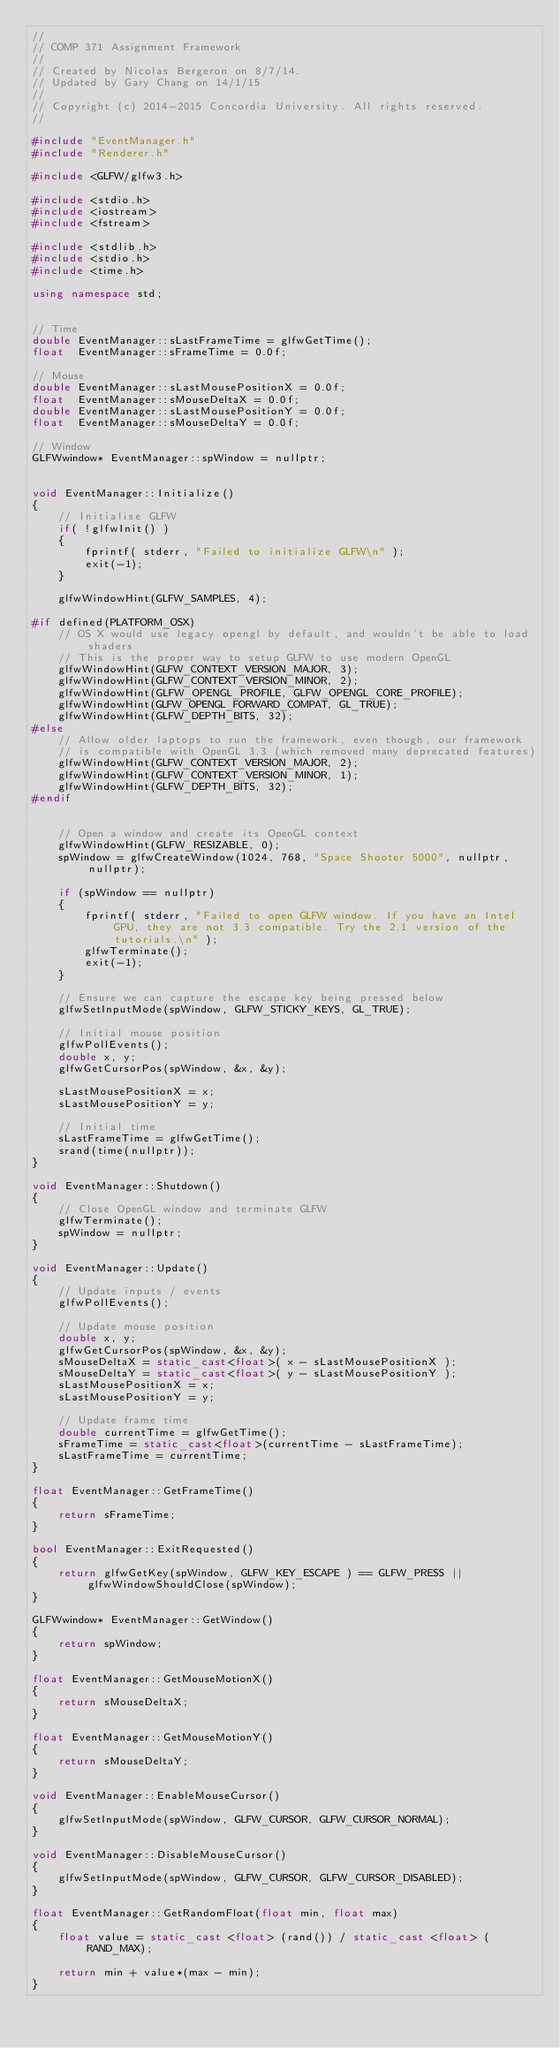Convert code to text. <code><loc_0><loc_0><loc_500><loc_500><_C++_>//
// COMP 371 Assignment Framework
//
// Created by Nicolas Bergeron on 8/7/14.
// Updated by Gary Chang on 14/1/15
//
// Copyright (c) 2014-2015 Concordia University. All rights reserved.
//

#include "EventManager.h"
#include "Renderer.h"

#include <GLFW/glfw3.h>

#include <stdio.h>
#include <iostream>
#include <fstream>

#include <stdlib.h>
#include <stdio.h>
#include <time.h>

using namespace std;


// Time
double EventManager::sLastFrameTime = glfwGetTime();
float  EventManager::sFrameTime = 0.0f;

// Mouse
double EventManager::sLastMousePositionX = 0.0f;
float  EventManager::sMouseDeltaX = 0.0f;
double EventManager::sLastMousePositionY = 0.0f;
float  EventManager::sMouseDeltaY = 0.0f;

// Window
GLFWwindow* EventManager::spWindow = nullptr;


void EventManager::Initialize()
{
	// Initialise GLFW
	if( !glfwInit() )
	{
		fprintf( stderr, "Failed to initialize GLFW\n" );
		exit(-1);
	}
		
	glfwWindowHint(GLFW_SAMPLES, 4);
    
#if defined(PLATFORM_OSX)
    // OS X would use legacy opengl by default, and wouldn't be able to load shaders
    // This is the proper way to setup GLFW to use modern OpenGL
    glfwWindowHint(GLFW_CONTEXT_VERSION_MAJOR, 3);
    glfwWindowHint(GLFW_CONTEXT_VERSION_MINOR, 2);
    glfwWindowHint(GLFW_OPENGL_PROFILE, GLFW_OPENGL_CORE_PROFILE);
    glfwWindowHint(GLFW_OPENGL_FORWARD_COMPAT, GL_TRUE);
	glfwWindowHint(GLFW_DEPTH_BITS, 32);
#else
    // Allow older laptops to run the framework, even though, our framework
    // is compatible with OpenGL 3.3 (which removed many deprecated features)
	glfwWindowHint(GLFW_CONTEXT_VERSION_MAJOR, 2);
	glfwWindowHint(GLFW_CONTEXT_VERSION_MINOR, 1);
	glfwWindowHint(GLFW_DEPTH_BITS, 32);
#endif
    
    
	// Open a window and create its OpenGL context
	glfwWindowHint(GLFW_RESIZABLE, 0);
	spWindow = glfwCreateWindow(1024, 768, "Space Shooter 5000", nullptr, nullptr);

	if (spWindow == nullptr)
	{
		fprintf( stderr, "Failed to open GLFW window. If you have an Intel GPU, they are not 3.3 compatible. Try the 2.1 version of the tutorials.\n" );
		glfwTerminate();
		exit(-1);
	}

	// Ensure we can capture the escape key being pressed below
	glfwSetInputMode(spWindow, GLFW_STICKY_KEYS, GL_TRUE);

	// Initial mouse position
	glfwPollEvents();
	double x, y;
	glfwGetCursorPos(spWindow, &x, &y);

	sLastMousePositionX = x;
	sLastMousePositionY = y;

	// Initial time
	sLastFrameTime = glfwGetTime();
    srand(time(nullptr));
}

void EventManager::Shutdown()
{
	// Close OpenGL window and terminate GLFW
	glfwTerminate();
	spWindow = nullptr;
}

void EventManager::Update()
{
	// Update inputs / events
	glfwPollEvents();

	// Update mouse position
	double x, y;
	glfwGetCursorPos(spWindow, &x, &y);
	sMouseDeltaX = static_cast<float>( x - sLastMousePositionX );
	sMouseDeltaY = static_cast<float>( y - sLastMousePositionY );
	sLastMousePositionX = x;
	sLastMousePositionY = y;

	// Update frame time
	double currentTime = glfwGetTime();
	sFrameTime = static_cast<float>(currentTime - sLastFrameTime);
	sLastFrameTime = currentTime;
}

float EventManager::GetFrameTime()
{
	return sFrameTime;
}

bool EventManager::ExitRequested()
{
	return glfwGetKey(spWindow, GLFW_KEY_ESCAPE ) == GLFW_PRESS || glfwWindowShouldClose(spWindow);
}

GLFWwindow* EventManager::GetWindow()
{
	return spWindow;
}

float EventManager::GetMouseMotionX()
{
	return sMouseDeltaX;
}

float EventManager::GetMouseMotionY()
{
	return sMouseDeltaY;
}

void EventManager::EnableMouseCursor()
{
	glfwSetInputMode(spWindow, GLFW_CURSOR, GLFW_CURSOR_NORMAL);
}

void EventManager::DisableMouseCursor()
{
	glfwSetInputMode(spWindow, GLFW_CURSOR, GLFW_CURSOR_DISABLED);
}

float EventManager::GetRandomFloat(float min, float max)
{
    float value = static_cast <float> (rand()) / static_cast <float> (RAND_MAX);

    return min + value*(max - min);
}
</code> 